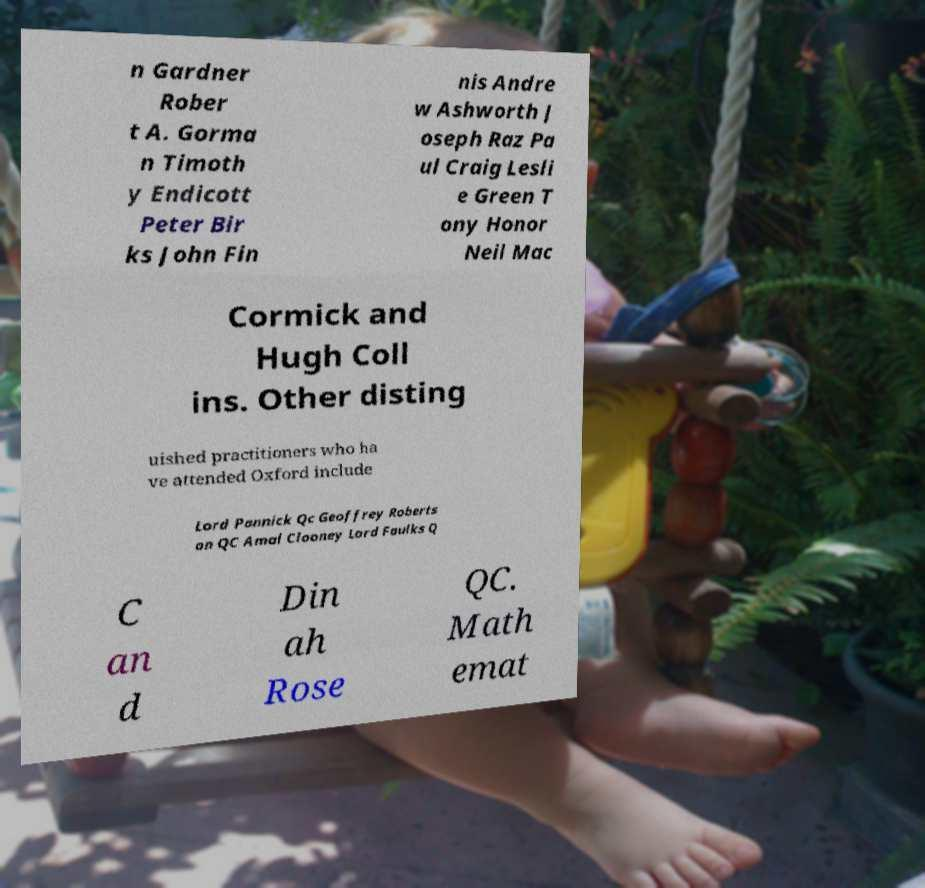What messages or text are displayed in this image? I need them in a readable, typed format. n Gardner Rober t A. Gorma n Timoth y Endicott Peter Bir ks John Fin nis Andre w Ashworth J oseph Raz Pa ul Craig Lesli e Green T ony Honor Neil Mac Cormick and Hugh Coll ins. Other disting uished practitioners who ha ve attended Oxford include Lord Pannick Qc Geoffrey Roberts on QC Amal Clooney Lord Faulks Q C an d Din ah Rose QC. Math emat 